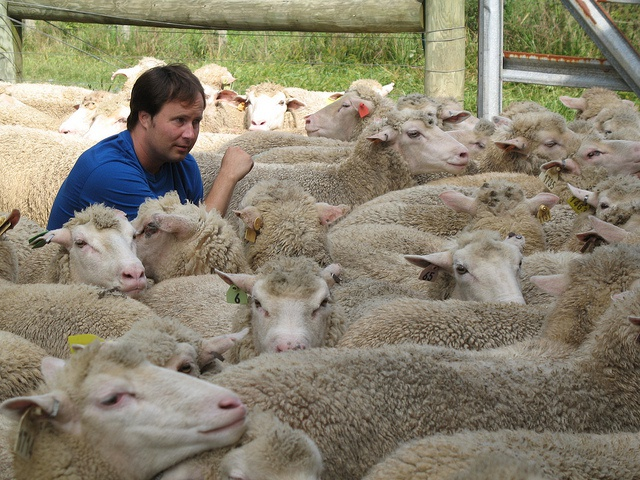Describe the objects in this image and their specific colors. I can see sheep in beige, darkgray, tan, gray, and ivory tones, sheep in beige, gray, darkgray, and black tones, sheep in beige, darkgray, and gray tones, people in beige, black, navy, blue, and brown tones, and sheep in beige, darkgray, and gray tones in this image. 